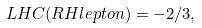Convert formula to latex. <formula><loc_0><loc_0><loc_500><loc_500>L H C ( R H l e p t o n ) = - 2 / 3 ,</formula> 